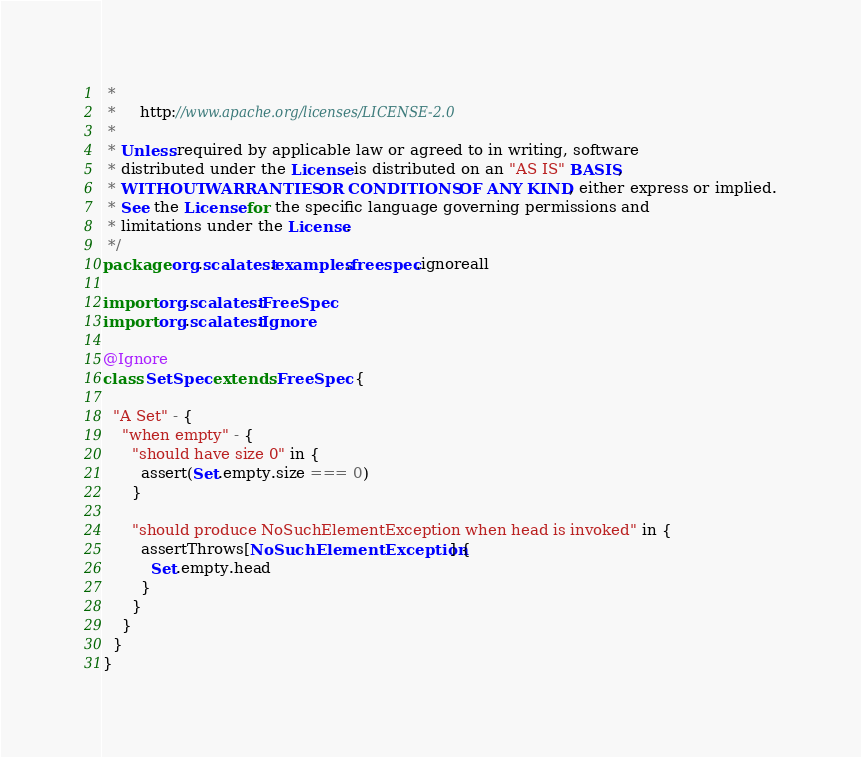Convert code to text. <code><loc_0><loc_0><loc_500><loc_500><_Scala_> *
 *     http://www.apache.org/licenses/LICENSE-2.0
 *
 * Unless required by applicable law or agreed to in writing, software
 * distributed under the License is distributed on an "AS IS" BASIS,
 * WITHOUT WARRANTIES OR CONDITIONS OF ANY KIND, either express or implied.
 * See the License for the specific language governing permissions and
 * limitations under the License.
 */
package org.scalatest.examples.freespec.ignoreall

import org.scalatest.FreeSpec
import org.scalatest.Ignore

@Ignore
class SetSpec extends FreeSpec {
  
  "A Set" - {
    "when empty" - {
      "should have size 0" in {
        assert(Set.empty.size === 0)
      }
      
      "should produce NoSuchElementException when head is invoked" in {
        assertThrows[NoSuchElementException] {
          Set.empty.head
        }
      }
    }
  }
}
</code> 